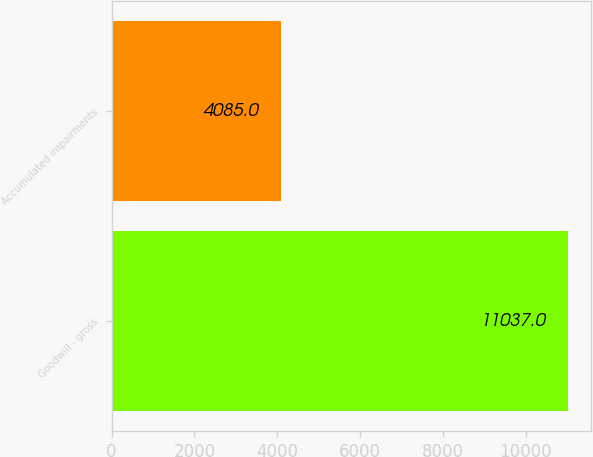<chart> <loc_0><loc_0><loc_500><loc_500><bar_chart><fcel>Goodwill - gross<fcel>Accumulated impairments<nl><fcel>11037<fcel>4085<nl></chart> 